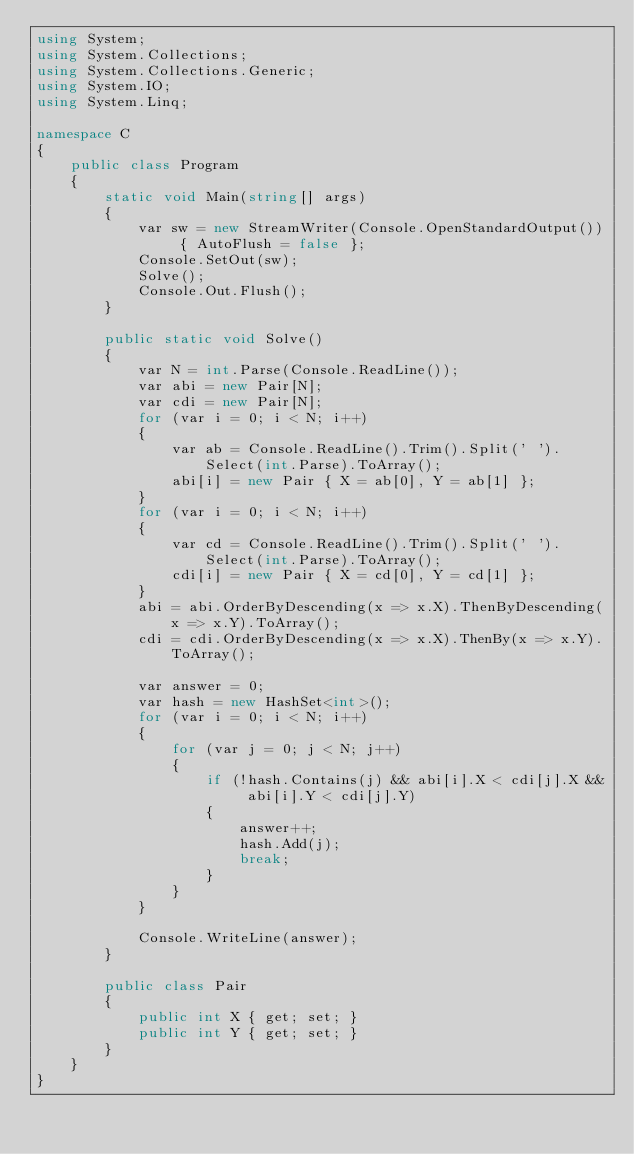<code> <loc_0><loc_0><loc_500><loc_500><_C#_>using System;
using System.Collections;
using System.Collections.Generic;
using System.IO;
using System.Linq;

namespace C
{
    public class Program
    {
        static void Main(string[] args)
        {
            var sw = new StreamWriter(Console.OpenStandardOutput()) { AutoFlush = false };
            Console.SetOut(sw);
            Solve();
            Console.Out.Flush();
        }

        public static void Solve()
        {
            var N = int.Parse(Console.ReadLine());
            var abi = new Pair[N];
            var cdi = new Pair[N];
            for (var i = 0; i < N; i++)
            {
                var ab = Console.ReadLine().Trim().Split(' ').Select(int.Parse).ToArray();
                abi[i] = new Pair { X = ab[0], Y = ab[1] };
            }
            for (var i = 0; i < N; i++)
            {
                var cd = Console.ReadLine().Trim().Split(' ').Select(int.Parse).ToArray();
                cdi[i] = new Pair { X = cd[0], Y = cd[1] };
            }
            abi = abi.OrderByDescending(x => x.X).ThenByDescending(x => x.Y).ToArray();
            cdi = cdi.OrderByDescending(x => x.X).ThenBy(x => x.Y).ToArray();

            var answer = 0;
            var hash = new HashSet<int>();
            for (var i = 0; i < N; i++)
            {
                for (var j = 0; j < N; j++)
                {
                    if (!hash.Contains(j) && abi[i].X < cdi[j].X && abi[i].Y < cdi[j].Y)
                    {
                        answer++;
                        hash.Add(j);
                        break;
                    }
                }
            }

            Console.WriteLine(answer);
        }

        public class Pair
        {
            public int X { get; set; }
            public int Y { get; set; }
        }
    }
}
</code> 